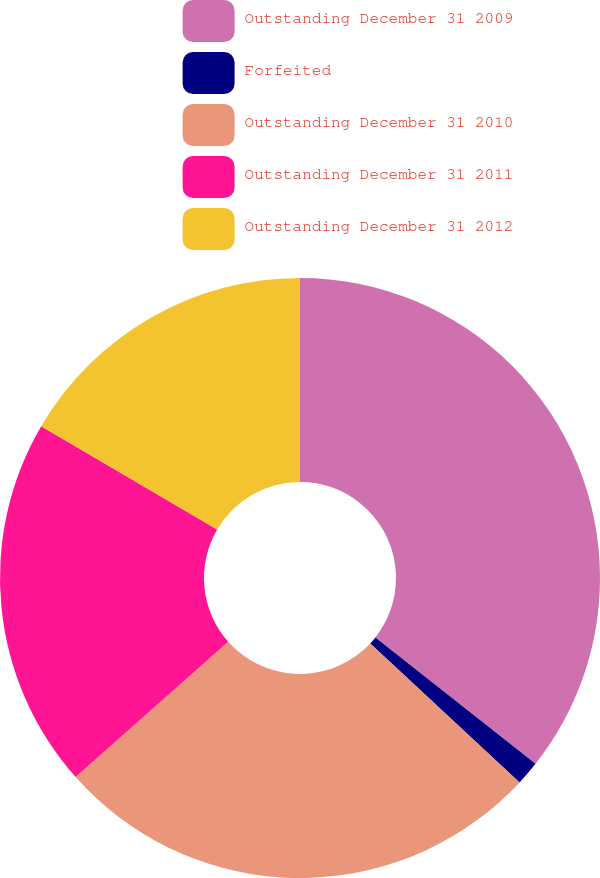<chart> <loc_0><loc_0><loc_500><loc_500><pie_chart><fcel>Outstanding December 31 2009<fcel>Forfeited<fcel>Outstanding December 31 2010<fcel>Outstanding December 31 2011<fcel>Outstanding December 31 2012<nl><fcel>35.63%<fcel>1.3%<fcel>26.52%<fcel>19.99%<fcel>16.56%<nl></chart> 